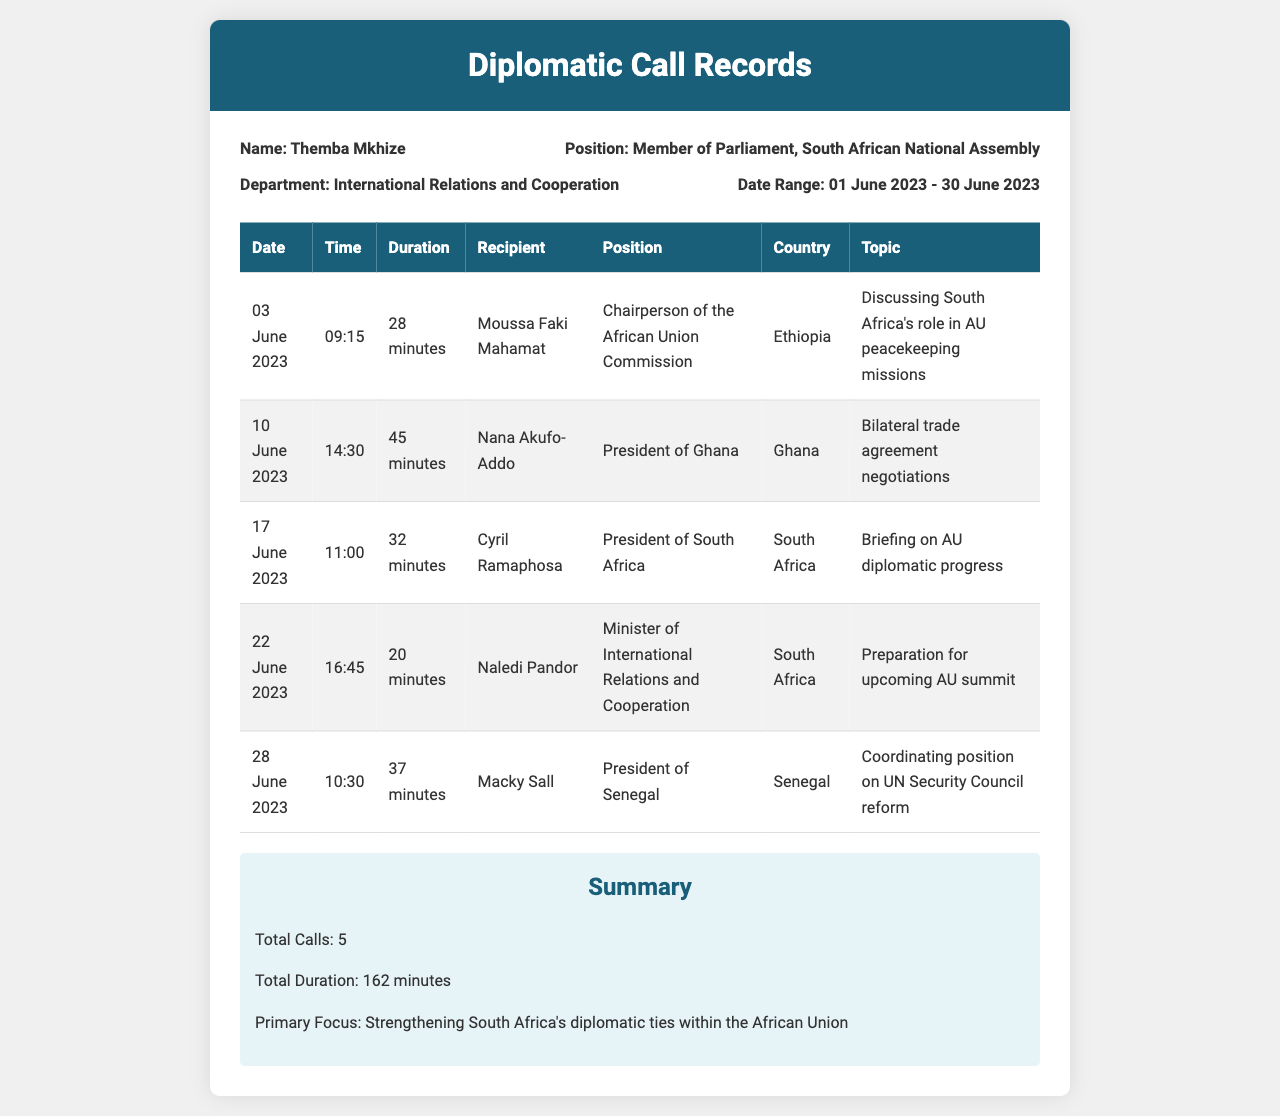What is the name of the person whose calls are recorded? The name is Themba Mkhize, as stated in the record information section.
Answer: Themba Mkhize What is the total duration of all calls made? The total duration is calculated by summing the durations of each call, which equals 162 minutes.
Answer: 162 minutes Who did Themba Mkhize call on 03 June 2023? This call was made to Moussa Faki Mahamat, as shown in the table.
Answer: Moussa Faki Mahamat What was the main topic of the call on 10 June 2023? The topic discussed was bilateral trade agreement negotiations with Nana Akufo-Addo.
Answer: Bilateral trade agreement negotiations How many calls were made to South African officials? There were two calls made to South African officials: Cyril Ramaphosa and Naledi Pandor.
Answer: 2 What is the position of the recipient called on 28 June 2023? The recipient, Macky Sall, is the President of Senegal.
Answer: President of Senegal Which country was discussed in the call about UN Security Council reform? The call discussed Senegal in relation to UN Security Council reform.
Answer: Senegal What is the primary focus of the diplomatic calls? The primary focus is on strengthening South Africa's diplomatic ties within the African Union.
Answer: Strengthening South Africa's diplomatic ties within the African Union What is the date of the last recorded call? The last recorded call took place on 28 June 2023, as indicated in the table.
Answer: 28 June 2023 